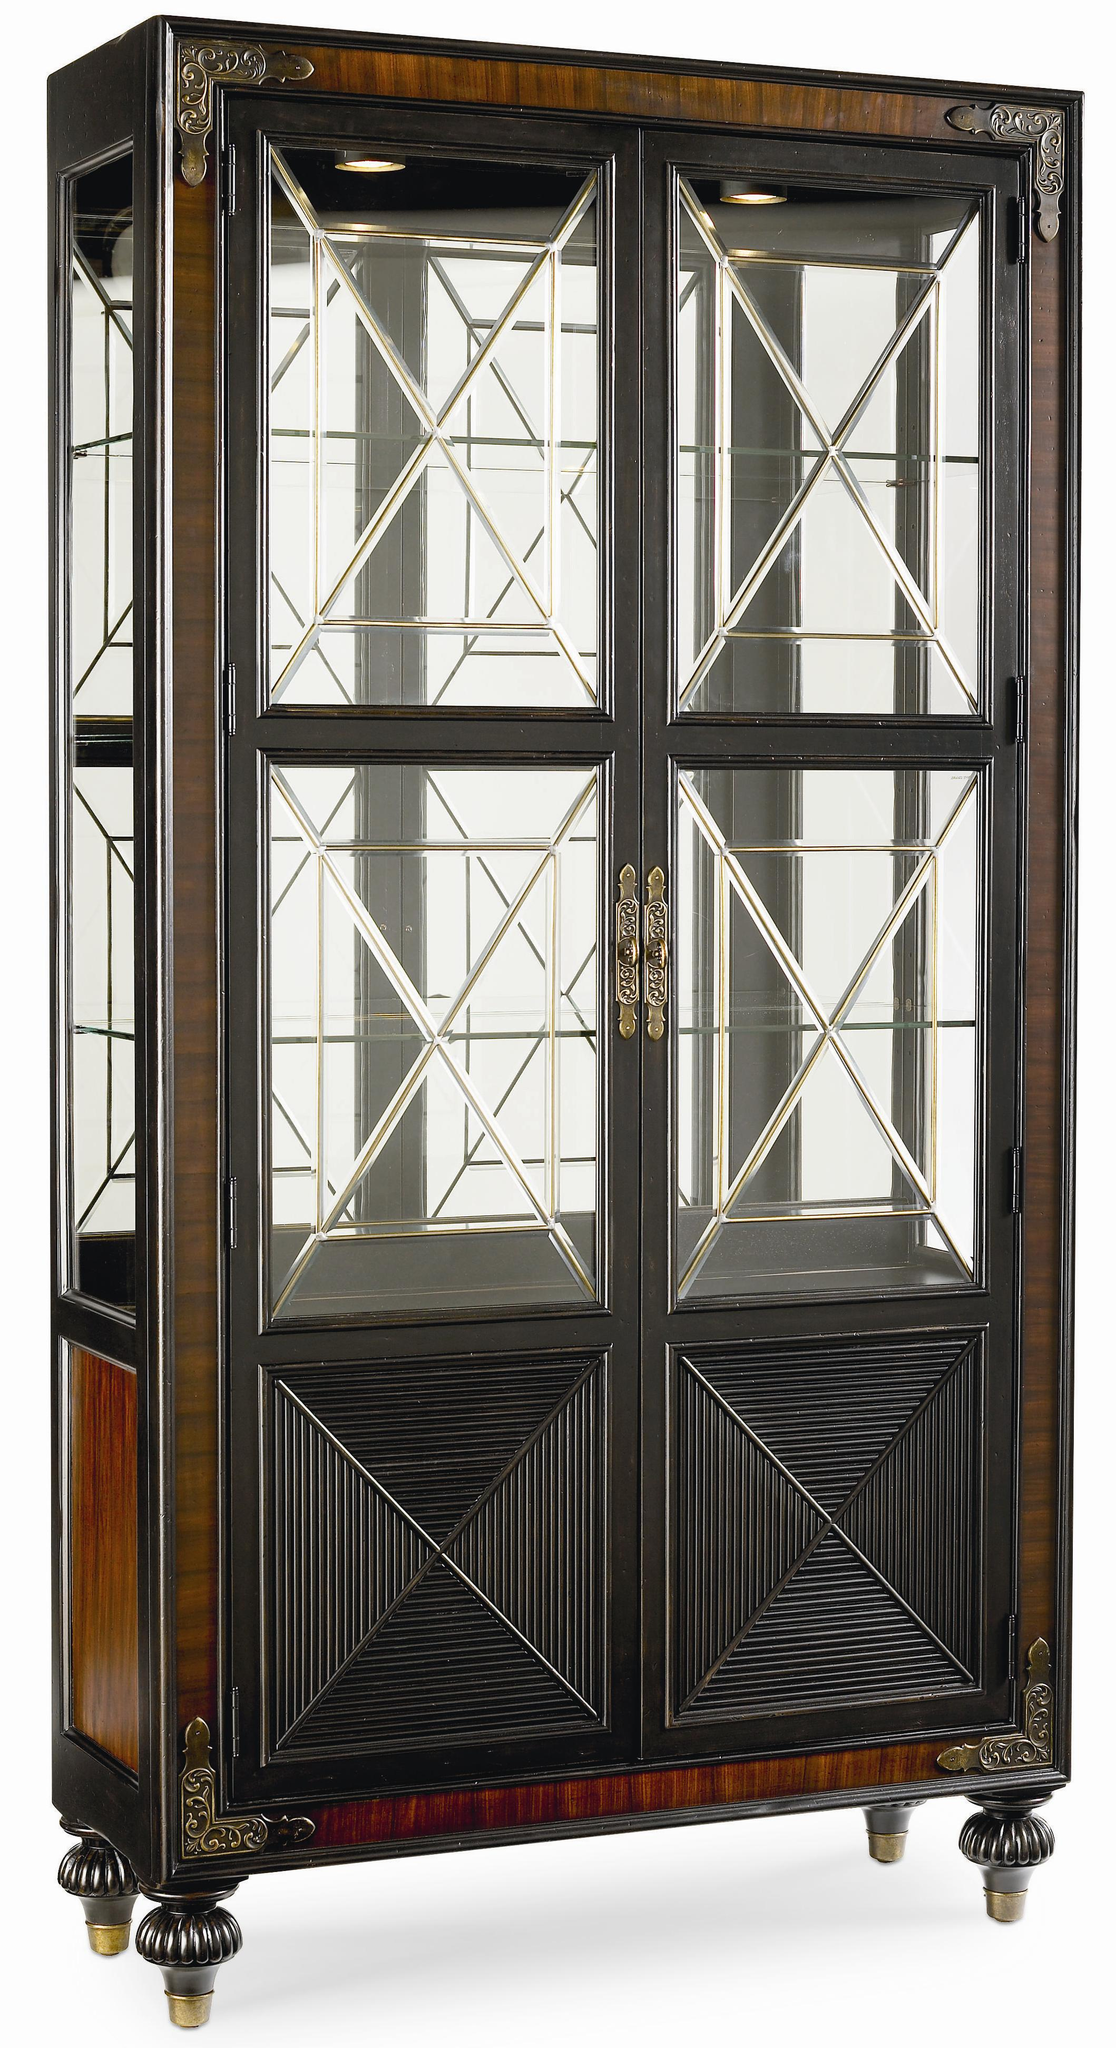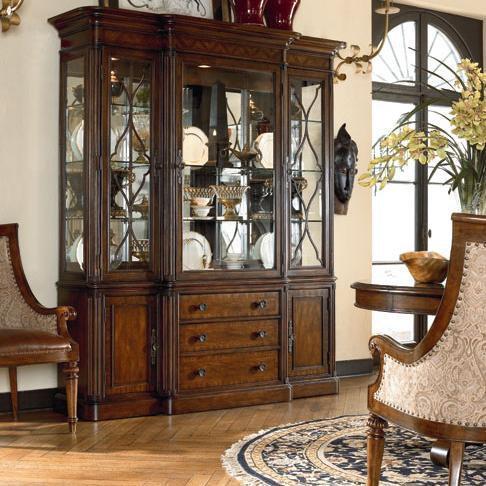The first image is the image on the left, the second image is the image on the right. Considering the images on both sides, is "The right hand image has a row of three drawers." valid? Answer yes or no. Yes. 